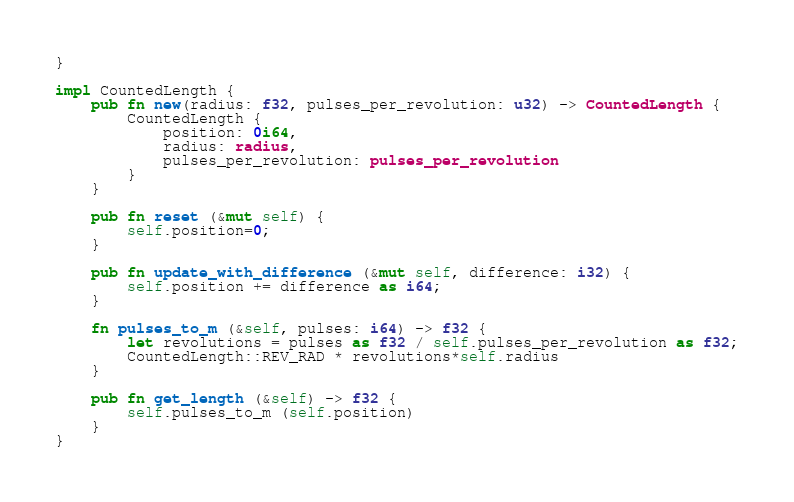<code> <loc_0><loc_0><loc_500><loc_500><_Rust_>}

impl CountedLength {
    pub fn new(radius: f32, pulses_per_revolution: u32) -> CountedLength {
        CountedLength {
            position: 0i64,
            radius: radius,
            pulses_per_revolution: pulses_per_revolution
        }
    }

    pub fn reset (&mut self) {
        self.position=0;
    }

    pub fn update_with_difference (&mut self, difference: i32) {
        self.position += difference as i64;
    }

    fn pulses_to_m (&self, pulses: i64) -> f32 {
        let revolutions = pulses as f32 / self.pulses_per_revolution as f32;
        CountedLength::REV_RAD * revolutions*self.radius
    }

    pub fn get_length (&self) -> f32 {
        self.pulses_to_m (self.position)
    }
}</code> 